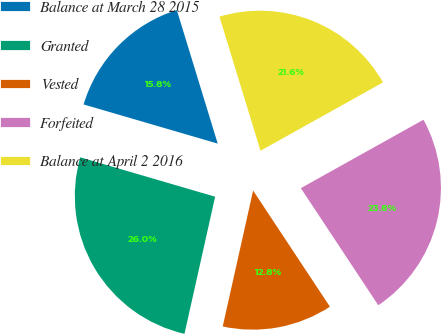Convert chart to OTSL. <chart><loc_0><loc_0><loc_500><loc_500><pie_chart><fcel>Balance at March 28 2015<fcel>Granted<fcel>Vested<fcel>Forfeited<fcel>Balance at April 2 2016<nl><fcel>15.75%<fcel>26.02%<fcel>12.8%<fcel>23.8%<fcel>21.63%<nl></chart> 